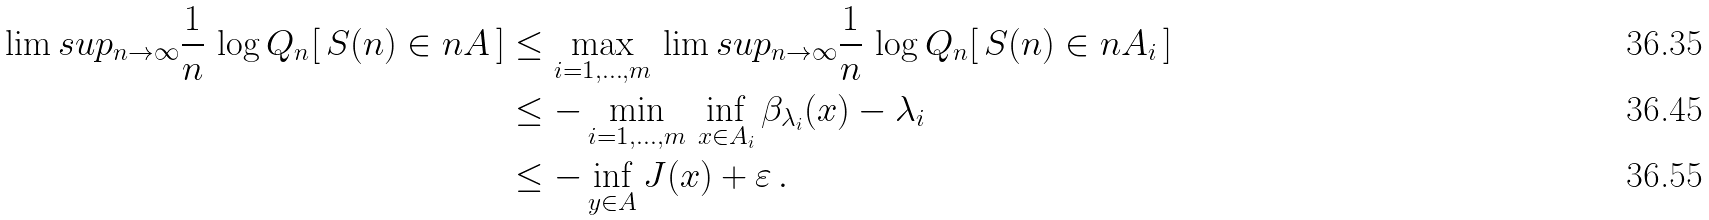<formula> <loc_0><loc_0><loc_500><loc_500>\lim s u p _ { n \to \infty } \frac { 1 } { n } \, \log Q _ { n } [ \, S ( n ) \in n A \, ] & \leq \max _ { i = 1 , \dots , m } \, \lim s u p _ { n \to \infty } \frac { 1 } { n } \, \log Q _ { n } [ \, S ( n ) \in n A _ { i } \, ] \\ & \leq - \min _ { i = 1 , \dots , m } \, \inf _ { x \in A _ { i } } \beta _ { \lambda _ { i } } ( x ) - \lambda _ { i } \\ & \leq - \inf _ { y \in A } J ( x ) + \varepsilon \, .</formula> 